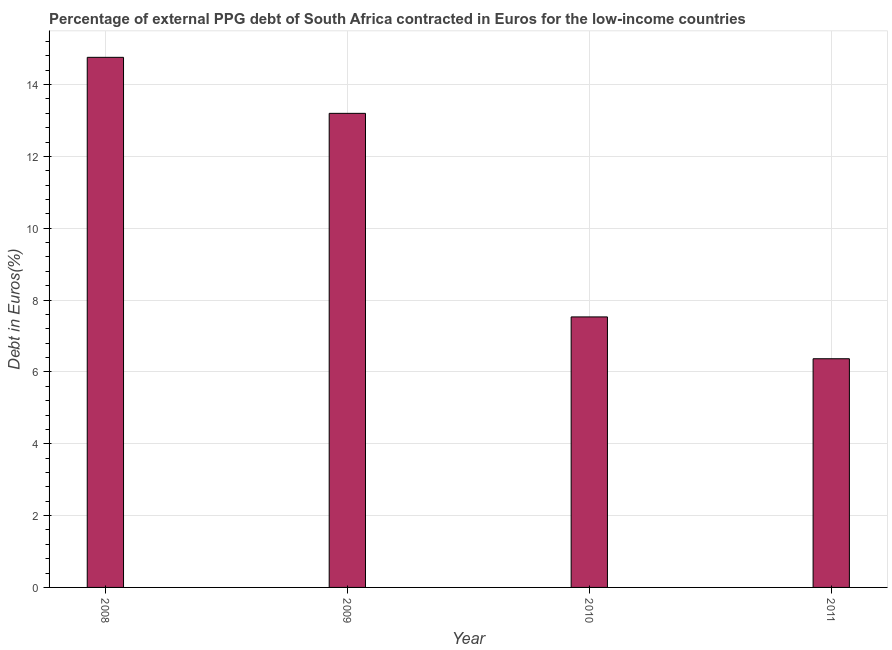Does the graph contain any zero values?
Make the answer very short. No. Does the graph contain grids?
Provide a short and direct response. Yes. What is the title of the graph?
Provide a short and direct response. Percentage of external PPG debt of South Africa contracted in Euros for the low-income countries. What is the label or title of the X-axis?
Offer a very short reply. Year. What is the label or title of the Y-axis?
Your response must be concise. Debt in Euros(%). What is the currency composition of ppg debt in 2010?
Your response must be concise. 7.53. Across all years, what is the maximum currency composition of ppg debt?
Make the answer very short. 14.76. Across all years, what is the minimum currency composition of ppg debt?
Offer a terse response. 6.37. In which year was the currency composition of ppg debt minimum?
Provide a succinct answer. 2011. What is the sum of the currency composition of ppg debt?
Provide a short and direct response. 41.85. What is the difference between the currency composition of ppg debt in 2008 and 2011?
Make the answer very short. 8.39. What is the average currency composition of ppg debt per year?
Keep it short and to the point. 10.46. What is the median currency composition of ppg debt?
Provide a succinct answer. 10.36. What is the ratio of the currency composition of ppg debt in 2008 to that in 2009?
Your answer should be very brief. 1.12. Is the difference between the currency composition of ppg debt in 2009 and 2010 greater than the difference between any two years?
Keep it short and to the point. No. What is the difference between the highest and the second highest currency composition of ppg debt?
Provide a short and direct response. 1.56. Is the sum of the currency composition of ppg debt in 2008 and 2009 greater than the maximum currency composition of ppg debt across all years?
Ensure brevity in your answer.  Yes. What is the difference between the highest and the lowest currency composition of ppg debt?
Provide a short and direct response. 8.39. In how many years, is the currency composition of ppg debt greater than the average currency composition of ppg debt taken over all years?
Your answer should be compact. 2. How many bars are there?
Provide a short and direct response. 4. Are the values on the major ticks of Y-axis written in scientific E-notation?
Provide a succinct answer. No. What is the Debt in Euros(%) in 2008?
Your response must be concise. 14.76. What is the Debt in Euros(%) in 2009?
Ensure brevity in your answer.  13.2. What is the Debt in Euros(%) in 2010?
Offer a very short reply. 7.53. What is the Debt in Euros(%) in 2011?
Your answer should be very brief. 6.37. What is the difference between the Debt in Euros(%) in 2008 and 2009?
Your answer should be compact. 1.56. What is the difference between the Debt in Euros(%) in 2008 and 2010?
Provide a succinct answer. 7.23. What is the difference between the Debt in Euros(%) in 2008 and 2011?
Your response must be concise. 8.39. What is the difference between the Debt in Euros(%) in 2009 and 2010?
Provide a succinct answer. 5.67. What is the difference between the Debt in Euros(%) in 2009 and 2011?
Make the answer very short. 6.83. What is the difference between the Debt in Euros(%) in 2010 and 2011?
Your answer should be compact. 1.16. What is the ratio of the Debt in Euros(%) in 2008 to that in 2009?
Keep it short and to the point. 1.12. What is the ratio of the Debt in Euros(%) in 2008 to that in 2010?
Provide a short and direct response. 1.96. What is the ratio of the Debt in Euros(%) in 2008 to that in 2011?
Make the answer very short. 2.32. What is the ratio of the Debt in Euros(%) in 2009 to that in 2010?
Provide a succinct answer. 1.75. What is the ratio of the Debt in Euros(%) in 2009 to that in 2011?
Give a very brief answer. 2.07. What is the ratio of the Debt in Euros(%) in 2010 to that in 2011?
Provide a short and direct response. 1.18. 